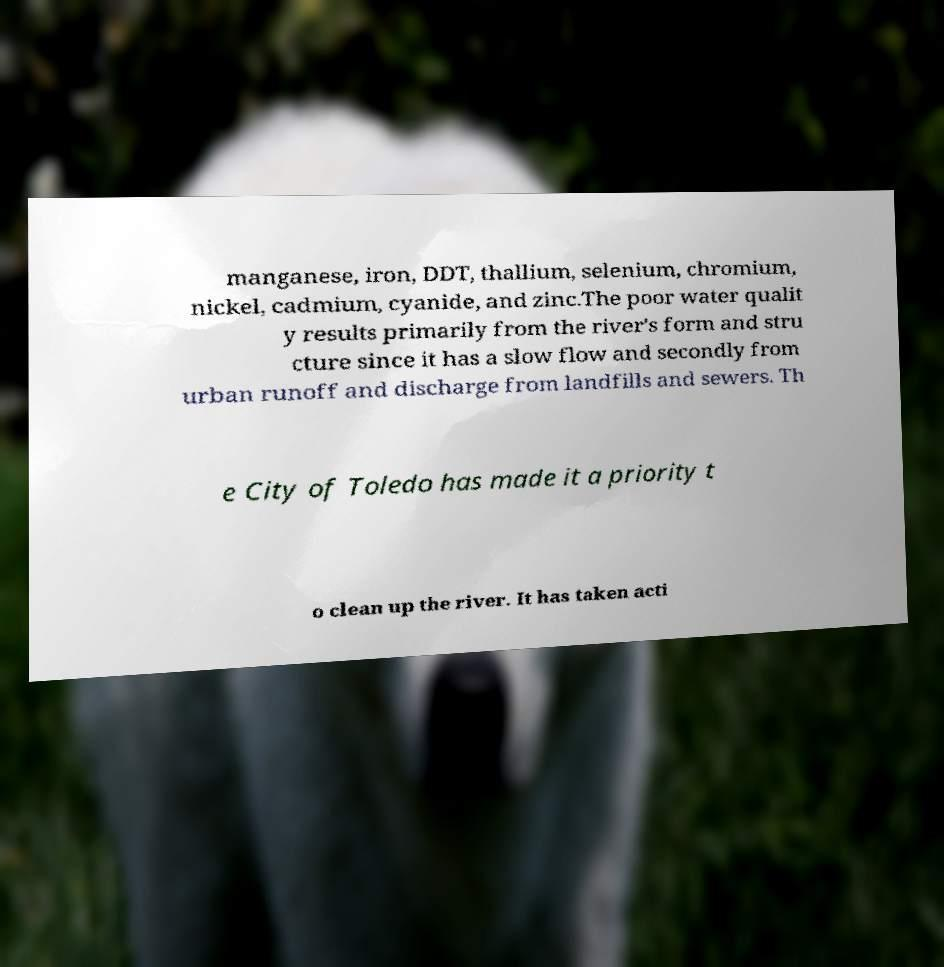For documentation purposes, I need the text within this image transcribed. Could you provide that? manganese, iron, DDT, thallium, selenium, chromium, nickel, cadmium, cyanide, and zinc.The poor water qualit y results primarily from the river's form and stru cture since it has a slow flow and secondly from urban runoff and discharge from landfills and sewers. Th e City of Toledo has made it a priority t o clean up the river. It has taken acti 